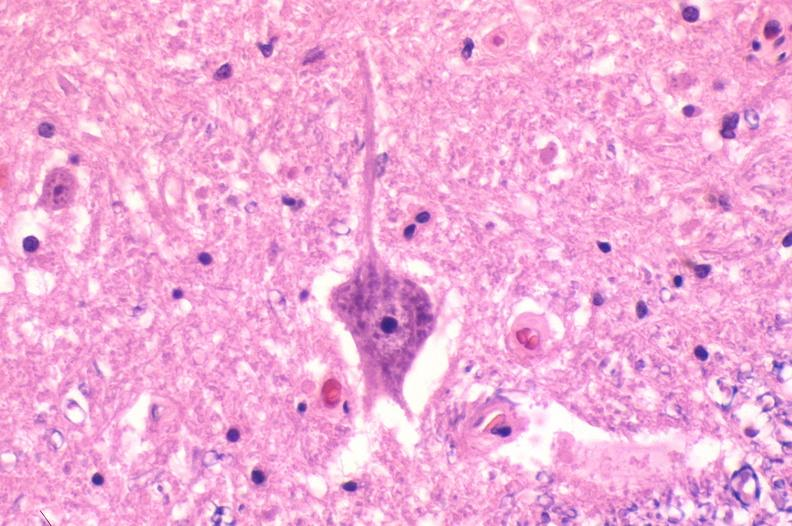what does this image show?
Answer the question using a single word or phrase. Spinal cord injury due to vertebral column trauma 